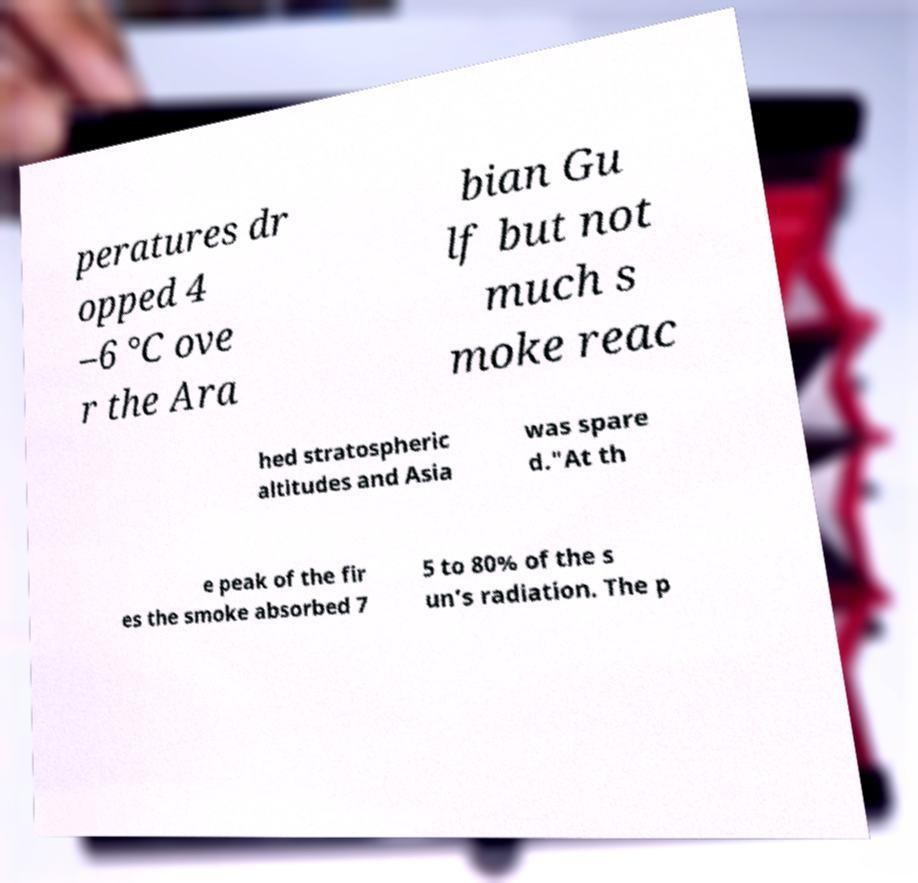For documentation purposes, I need the text within this image transcribed. Could you provide that? peratures dr opped 4 –6 °C ove r the Ara bian Gu lf but not much s moke reac hed stratospheric altitudes and Asia was spare d."At th e peak of the fir es the smoke absorbed 7 5 to 80% of the s un’s radiation. The p 